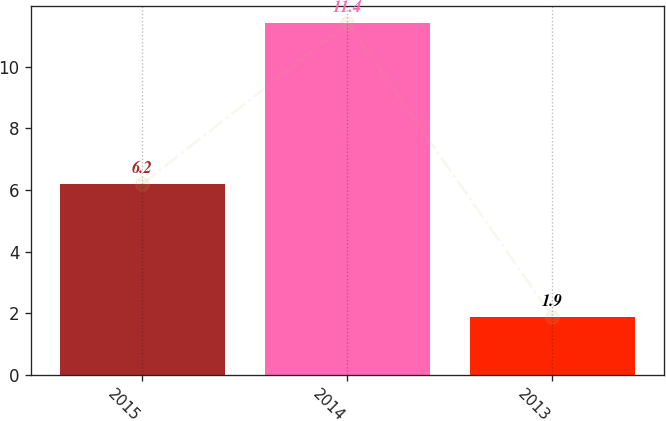Convert chart to OTSL. <chart><loc_0><loc_0><loc_500><loc_500><bar_chart><fcel>2015<fcel>2014<fcel>2013<nl><fcel>6.2<fcel>11.4<fcel>1.9<nl></chart> 